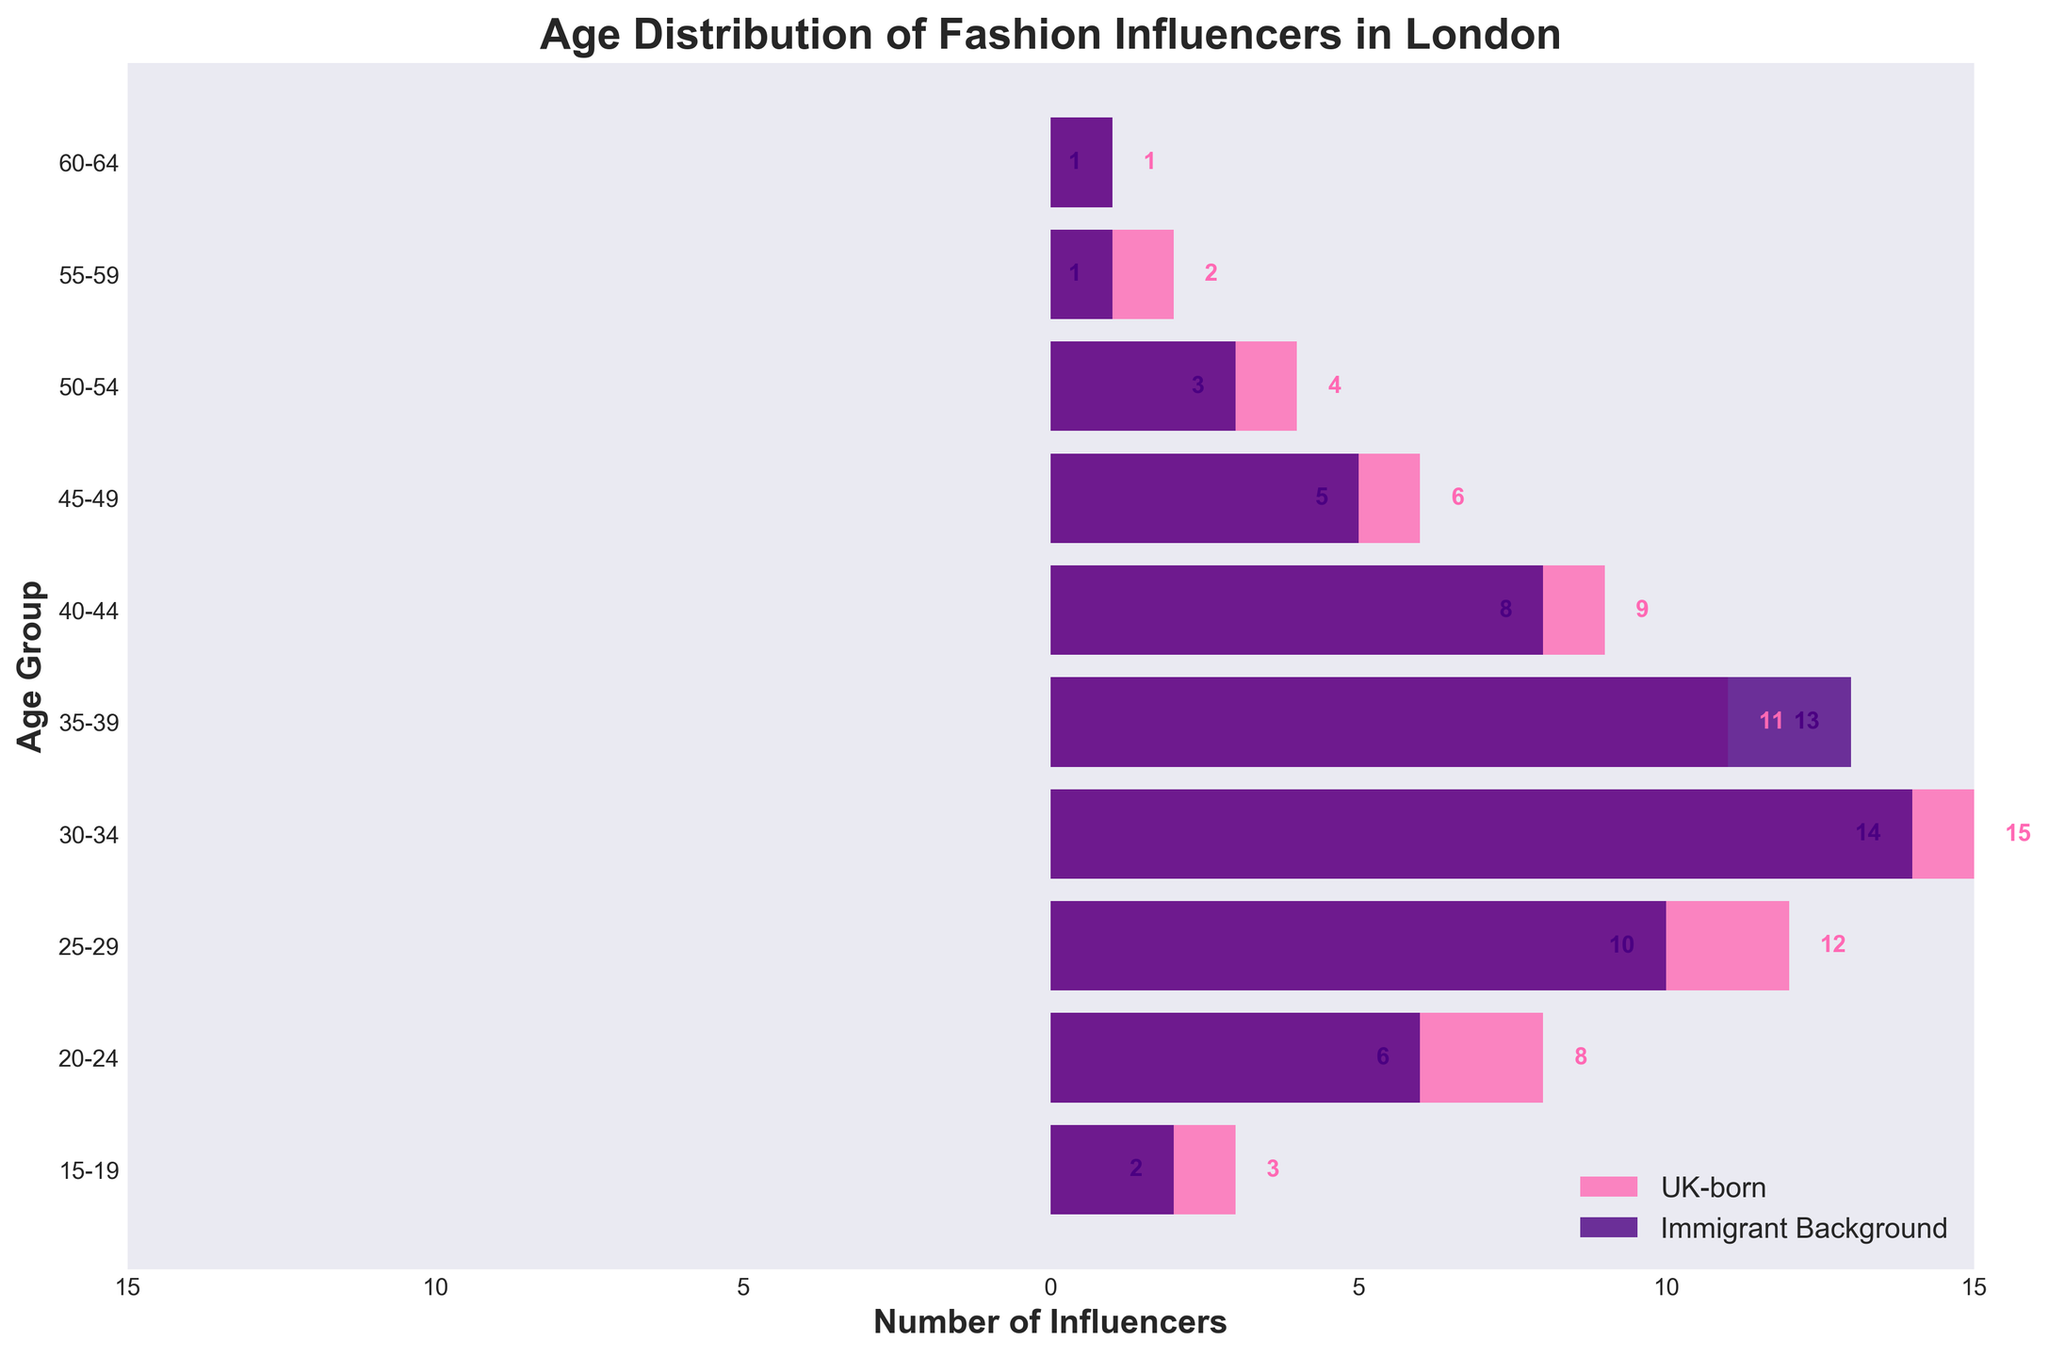What is the title of the figure? The title of the figure is displayed at the top and provides an overview of what the figure represents.
Answer: Age Distribution of Fashion Influencers in London What is the color used to represent UK-born influencers? The color used to represent UK-born influencers is seen in the horizontal bars on the left side of the figure.
Answer: Pink How many age groups are presented in the figure? Each age group is represented on the y-axis, starting from 15-19 and ending at 60-64. Counting these groups will give the total number.
Answer: 10 Which age group has the highest number of UK-born fashion influencers? By inspecting the length of the pink bars, the 30-34 age group has the longest bar for UK-born influencers.
Answer: 30-34 Which age group has the highest number of fashion influencers with an immigrant background? By inspecting the length of the purple bars, the 30-34 age group has the longest bar for influencers with an immigrant background.
Answer: 30-34 What is the total number of UK-born fashion influencers in the 25-44 age range? Add the values for UK-born influencers in the 25-29, 30-34, 35-39, and 40-44 age groups: 12 + 15 + 11 + 9.
Answer: 47 In the 35-39 age group, which group has more influencers, UK-born or immigrant background? Compare the lengths of the bars for the 35-39 age group: 11 (UK-born) vs. 13 (immigrant background).
Answer: Immigrant background What is the overall trend in the number of UK-born influencers as age increases? Observe the lengths of the pink bars from the youngest to the oldest age group. Generally, the number decreases after the 30-34 age group.
Answer: Decreasing trend What is the total number of influencers from both backgrounds in the 20-29 age range? Add the values for both UK-born and immigrant backgrounds in the 20-24 and 25-29 age groups: (8 + 12) + (6 + 10).
Answer: 36 Which age group has the smallest difference between the number of UK-born and immigrant background influencers? Calculate the absolute differences for each age group and identify the smallest one:
Answer: 60-64 